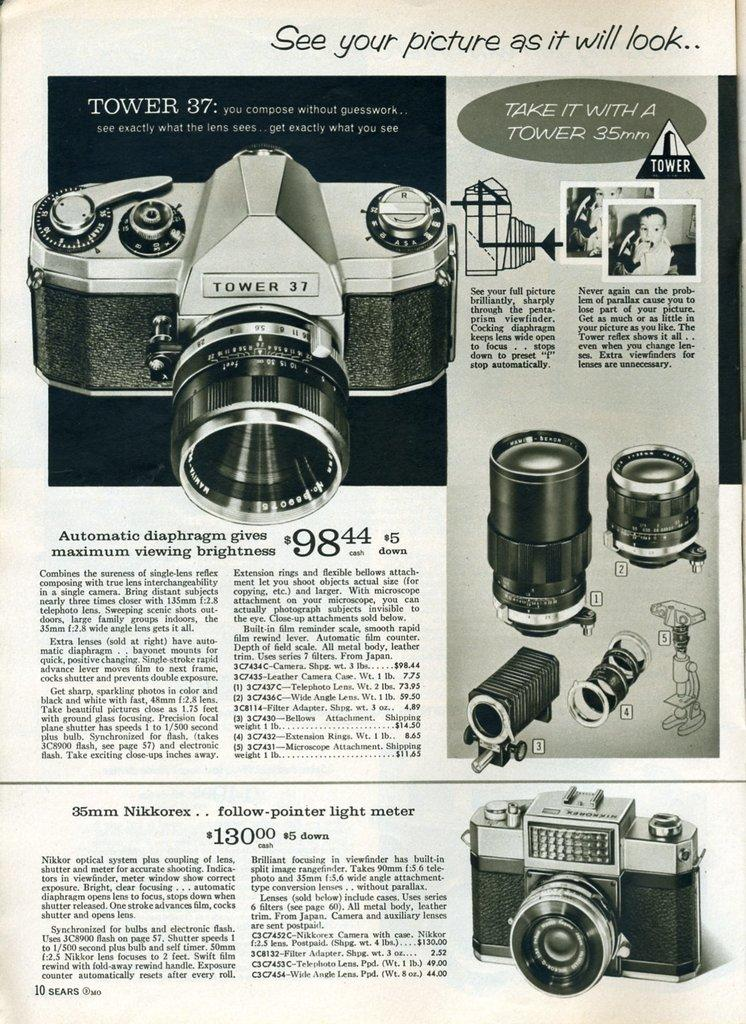What is the main subject of the image? The main subject of the image is a news article. What type of content is featured in the news article? The news article contains photos of cameras and a photo of a child. Is there any text accompanying the images in the news article? Yes, there is text written on the news article. How many horses are mentioned in the news article? There are no horses mentioned in the news article; it focuses on cameras and a child. What type of joke is included in the news article? There is no joke present in the news article; it is a serious news article about cameras and a child. 